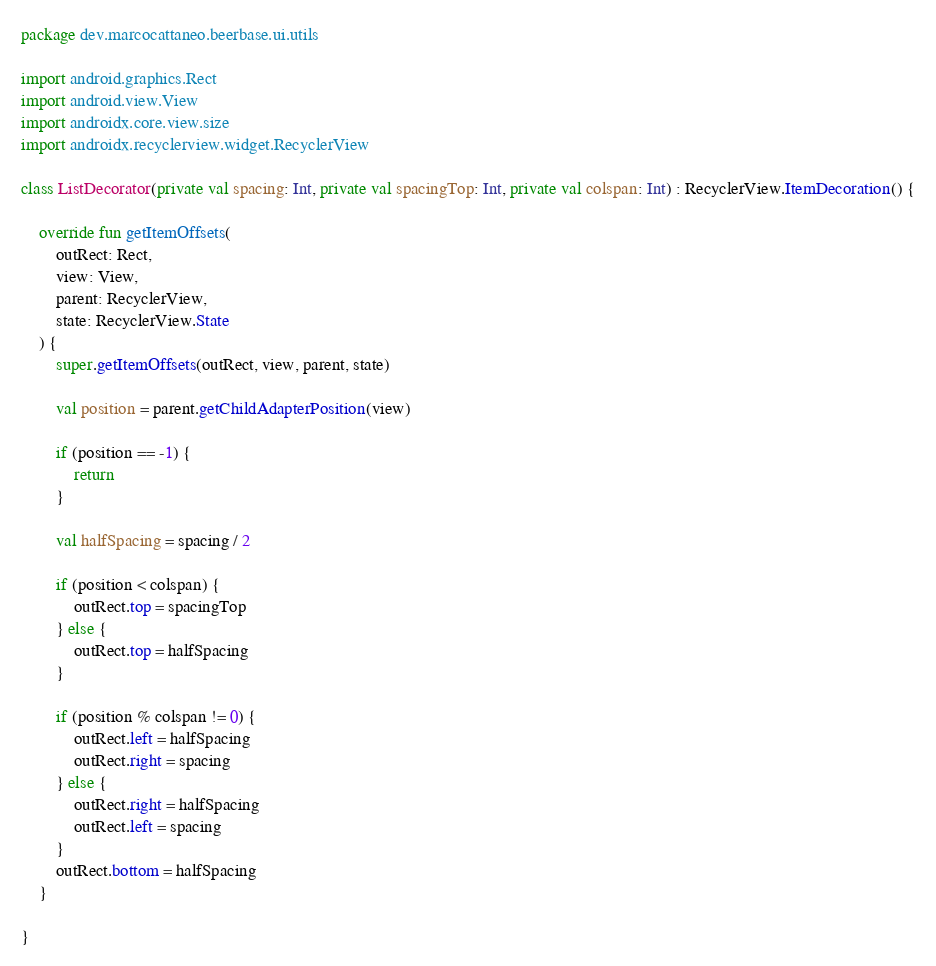Convert code to text. <code><loc_0><loc_0><loc_500><loc_500><_Kotlin_>package dev.marcocattaneo.beerbase.ui.utils

import android.graphics.Rect
import android.view.View
import androidx.core.view.size
import androidx.recyclerview.widget.RecyclerView

class ListDecorator(private val spacing: Int, private val spacingTop: Int, private val colspan: Int) : RecyclerView.ItemDecoration() {

    override fun getItemOffsets(
        outRect: Rect,
        view: View,
        parent: RecyclerView,
        state: RecyclerView.State
    ) {
        super.getItemOffsets(outRect, view, parent, state)

        val position = parent.getChildAdapterPosition(view)

        if (position == -1) {
            return
        }

        val halfSpacing = spacing / 2

        if (position < colspan) {
            outRect.top = spacingTop
        } else {
            outRect.top = halfSpacing
        }

        if (position % colspan != 0) {
            outRect.left = halfSpacing
            outRect.right = spacing
        } else {
            outRect.right = halfSpacing
            outRect.left = spacing
        }
        outRect.bottom = halfSpacing
    }

}</code> 